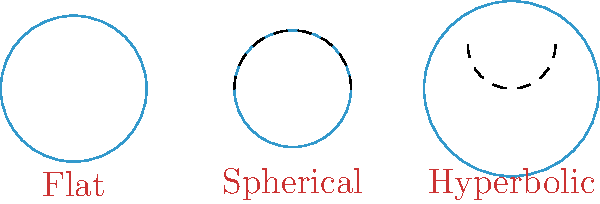As you contemplate the complexities of rebuilding relationships with your teenage children from a distance, consider the following question about Non-Euclidean Geometry:

Given circles of equal radius on flat, spherical, and hyperbolic planes, how does their area compare? Assume the spherical plane has positive curvature and the hyperbolic plane has negative curvature.

A) $A_{flat} > A_{spherical} > A_{hyperbolic}$
B) $A_{flat} < A_{spherical} < A_{hyperbolic}$
C) $A_{spherical} > A_{flat} > A_{hyperbolic}$
D) $A_{hyperbolic} > A_{flat} > A_{spherical}$ Let's approach this step-by-step:

1) On a flat (Euclidean) plane, the area of a circle is given by $A_{flat} = \pi r^2$.

2) On a spherical plane with positive curvature:
   - The circumference of the circle is smaller than on a flat plane.
   - This results in a smaller area: $A_{spherical} < \pi r^2$.

3) On a hyperbolic plane with negative curvature:
   - The circumference of the circle is larger than on a flat plane.
   - This leads to a larger area: $A_{hyperbolic} > \pi r^2$.

4) Comparing the three:
   $A_{hyperbolic} > A_{flat} > A_{spherical}$

This relationship holds true for circles of equal radius on these different geometries, reflecting how space itself curves differently in each case. Just as rebuilding relationships requires understanding different perspectives, Non-Euclidean Geometry challenges our intuitive understanding of space.
Answer: D) $A_{hyperbolic} > A_{flat} > A_{spherical}$ 